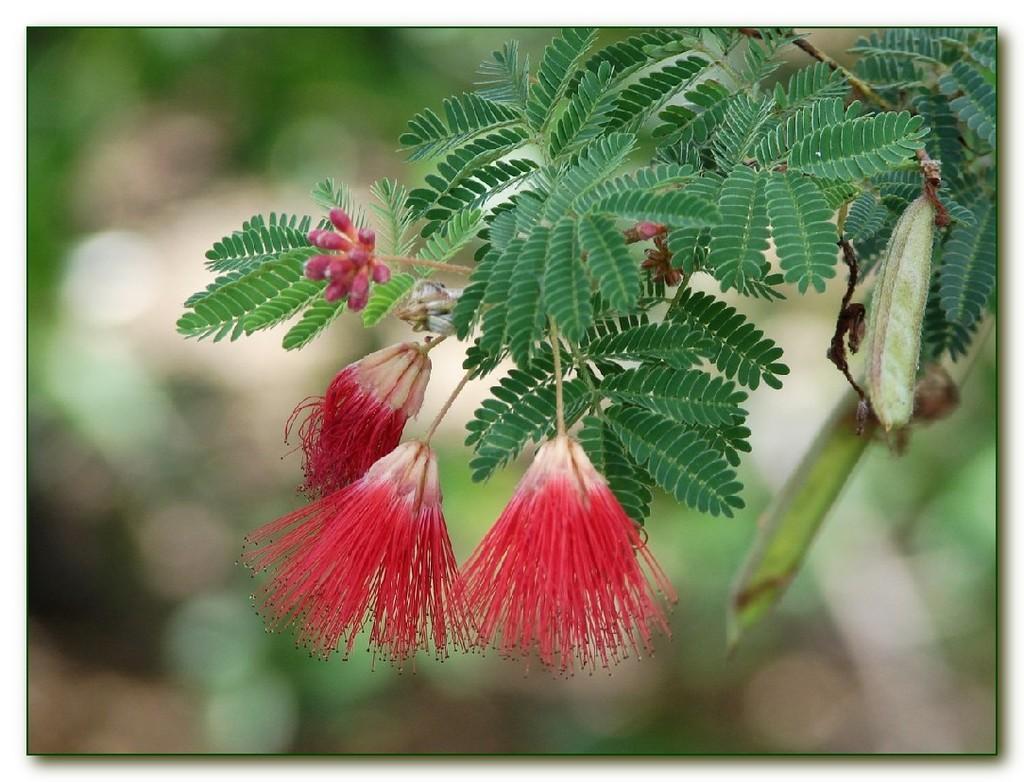Please provide a concise description of this image. In this image I can see few red color flowers and green color leaves. Background is blurred. 